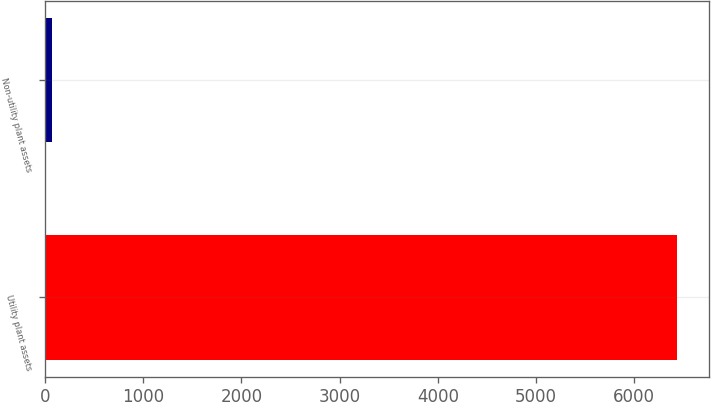Convert chart. <chart><loc_0><loc_0><loc_500><loc_500><bar_chart><fcel>Utility plant assets<fcel>Non-utility plant assets<nl><fcel>6439<fcel>71<nl></chart> 